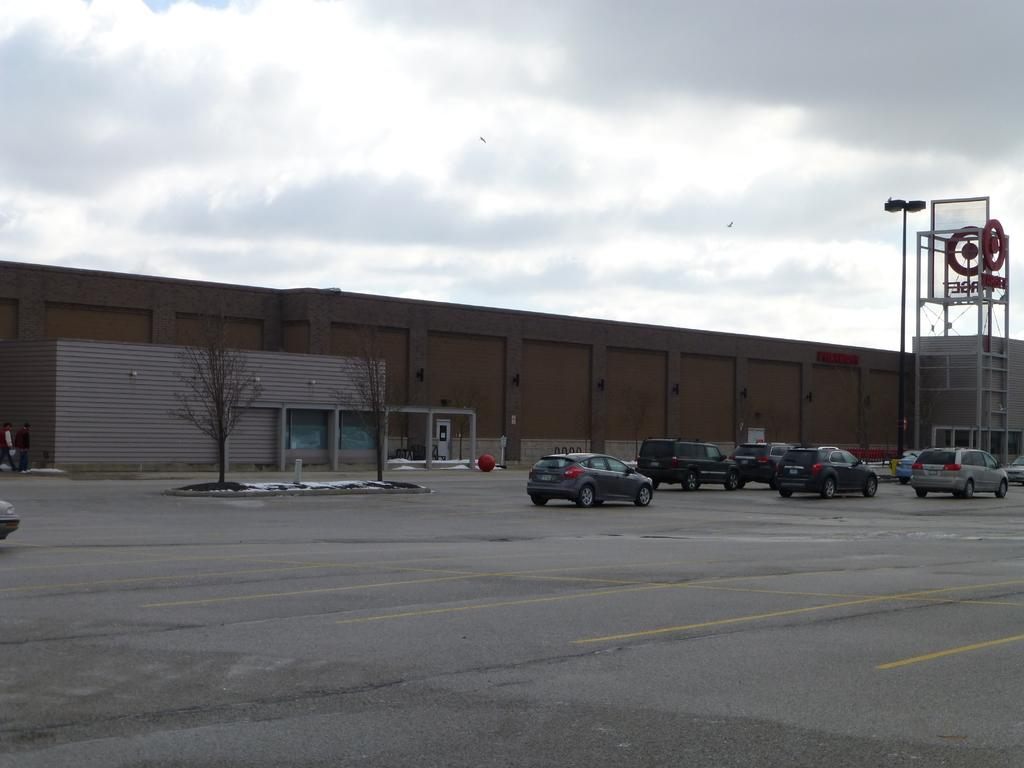What type of structures can be seen in the image? There are buildings and a shed in the image. What type of lighting is present in the image? Flood lights are present in the image. What else can be seen in the image besides structures? There is a pole, trees, and a motor vehicle on the road in the image. What is visible in the background of the image? The sky is visible in the image, and clouds are present in the sky. What type of pleasure can be seen in the image? There is no indication of pleasure in the image; it features buildings, a shed, flood lights, a pole, trees, a motor vehicle, and the sky with clouds. How many planes are visible in the image? There are no planes visible in the image. What type of light is emitted from the motor vehicle in the image? The provided facts do not mention any light emitted from the motor vehicle in the image. 